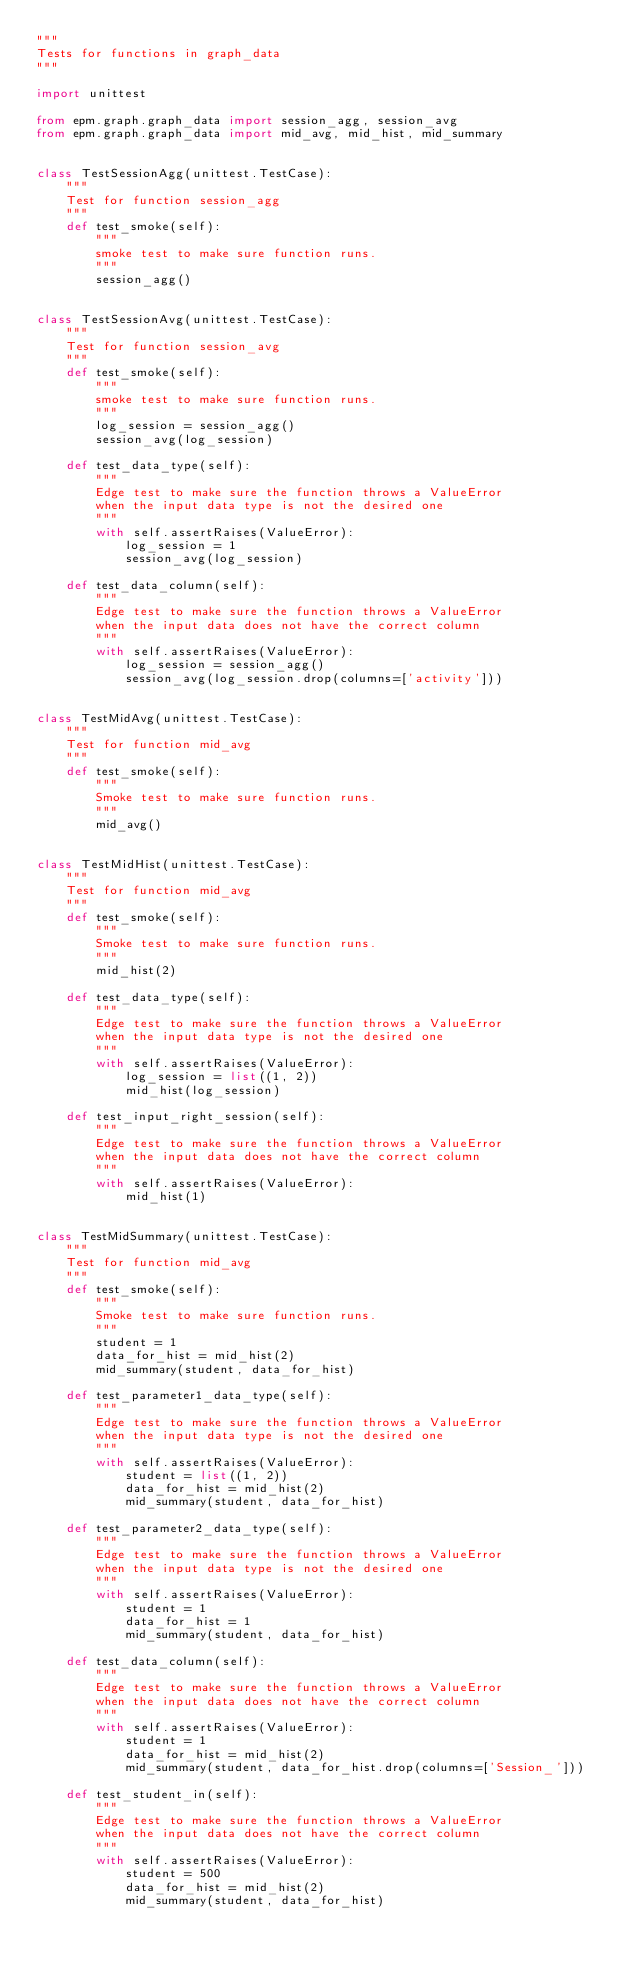<code> <loc_0><loc_0><loc_500><loc_500><_Python_>"""
Tests for functions in graph_data
"""

import unittest

from epm.graph.graph_data import session_agg, session_avg
from epm.graph.graph_data import mid_avg, mid_hist, mid_summary


class TestSessionAgg(unittest.TestCase):
    """
    Test for function session_agg
    """
    def test_smoke(self):
        """
        smoke test to make sure function runs.
        """
        session_agg()


class TestSessionAvg(unittest.TestCase):
    """
    Test for function session_avg
    """
    def test_smoke(self):
        """
        smoke test to make sure function runs.
        """
        log_session = session_agg()
        session_avg(log_session)

    def test_data_type(self):
        """
        Edge test to make sure the function throws a ValueError
        when the input data type is not the desired one
        """
        with self.assertRaises(ValueError):
            log_session = 1
            session_avg(log_session)

    def test_data_column(self):
        """
        Edge test to make sure the function throws a ValueError
        when the input data does not have the correct column
        """
        with self.assertRaises(ValueError):
            log_session = session_agg()
            session_avg(log_session.drop(columns=['activity']))


class TestMidAvg(unittest.TestCase):
    """
    Test for function mid_avg
    """
    def test_smoke(self):
        """
        Smoke test to make sure function runs.
        """
        mid_avg()


class TestMidHist(unittest.TestCase):
    """
    Test for function mid_avg
    """
    def test_smoke(self):
        """
        Smoke test to make sure function runs.
        """
        mid_hist(2)

    def test_data_type(self):
        """
        Edge test to make sure the function throws a ValueError
        when the input data type is not the desired one
        """
        with self.assertRaises(ValueError):
            log_session = list((1, 2))
            mid_hist(log_session)

    def test_input_right_session(self):
        """
        Edge test to make sure the function throws a ValueError
        when the input data does not have the correct column
        """
        with self.assertRaises(ValueError):
            mid_hist(1)


class TestMidSummary(unittest.TestCase):
    """
    Test for function mid_avg
    """
    def test_smoke(self):
        """
        Smoke test to make sure function runs.
        """
        student = 1
        data_for_hist = mid_hist(2)
        mid_summary(student, data_for_hist)

    def test_parameter1_data_type(self):
        """
        Edge test to make sure the function throws a ValueError
        when the input data type is not the desired one
        """
        with self.assertRaises(ValueError):
            student = list((1, 2))
            data_for_hist = mid_hist(2)
            mid_summary(student, data_for_hist)

    def test_parameter2_data_type(self):
        """
        Edge test to make sure the function throws a ValueError
        when the input data type is not the desired one
        """
        with self.assertRaises(ValueError):
            student = 1
            data_for_hist = 1
            mid_summary(student, data_for_hist)

    def test_data_column(self):
        """
        Edge test to make sure the function throws a ValueError
        when the input data does not have the correct column
        """
        with self.assertRaises(ValueError):
            student = 1
            data_for_hist = mid_hist(2)
            mid_summary(student, data_for_hist.drop(columns=['Session_']))

    def test_student_in(self):
        """
        Edge test to make sure the function throws a ValueError
        when the input data does not have the correct column
        """
        with self.assertRaises(ValueError):
            student = 500
            data_for_hist = mid_hist(2)
            mid_summary(student, data_for_hist)
</code> 